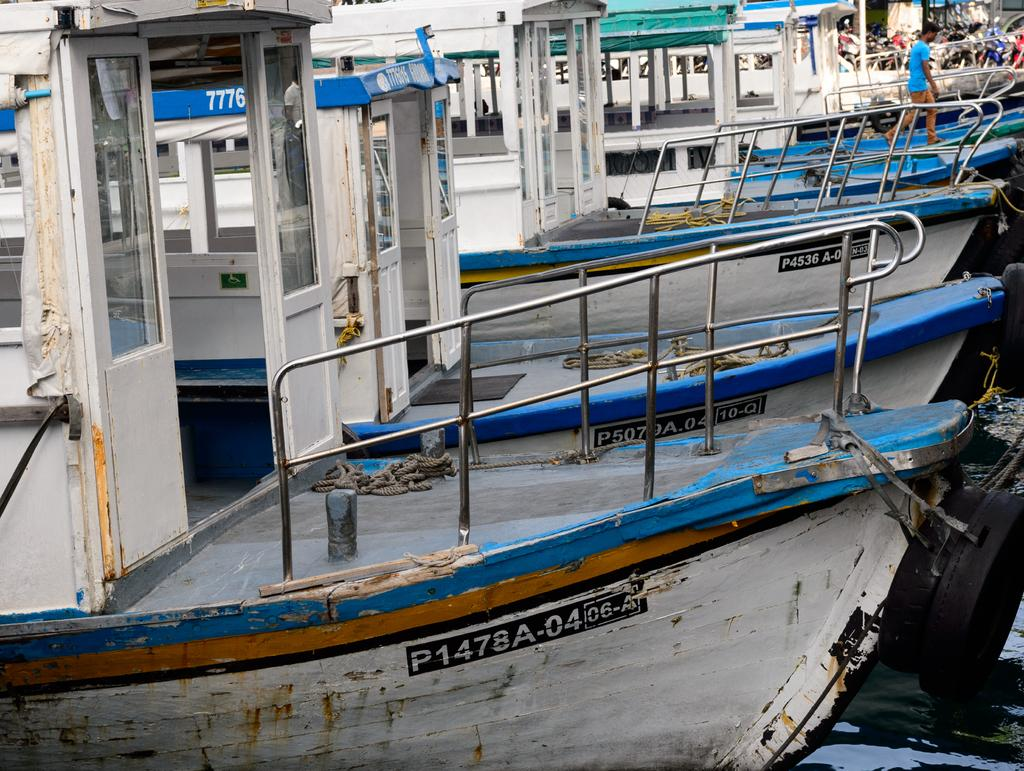What is in the water in the image? There are boats in the water in the image. What objects can be seen on the right side of the image? There are two tyres on the right side of the image. What is the person in the image doing? There is a person walking on a boat in the image. What color of paint is being used to cover the aftermath of the storm in the image? There is no mention of a storm or paint in the image, so we cannot answer this question. 